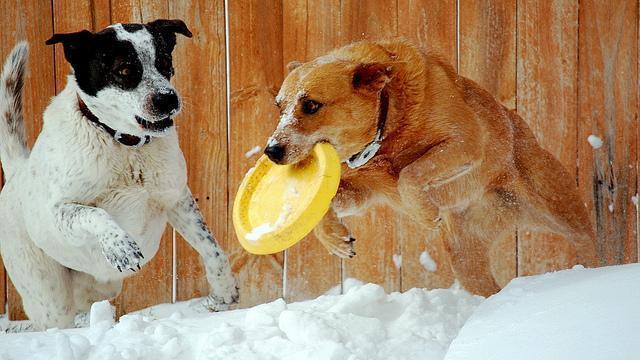What game are they playing?
From the following four choices, select the correct answer to address the question.
Options: Running, fetch, stretching, tag. Fetch. 